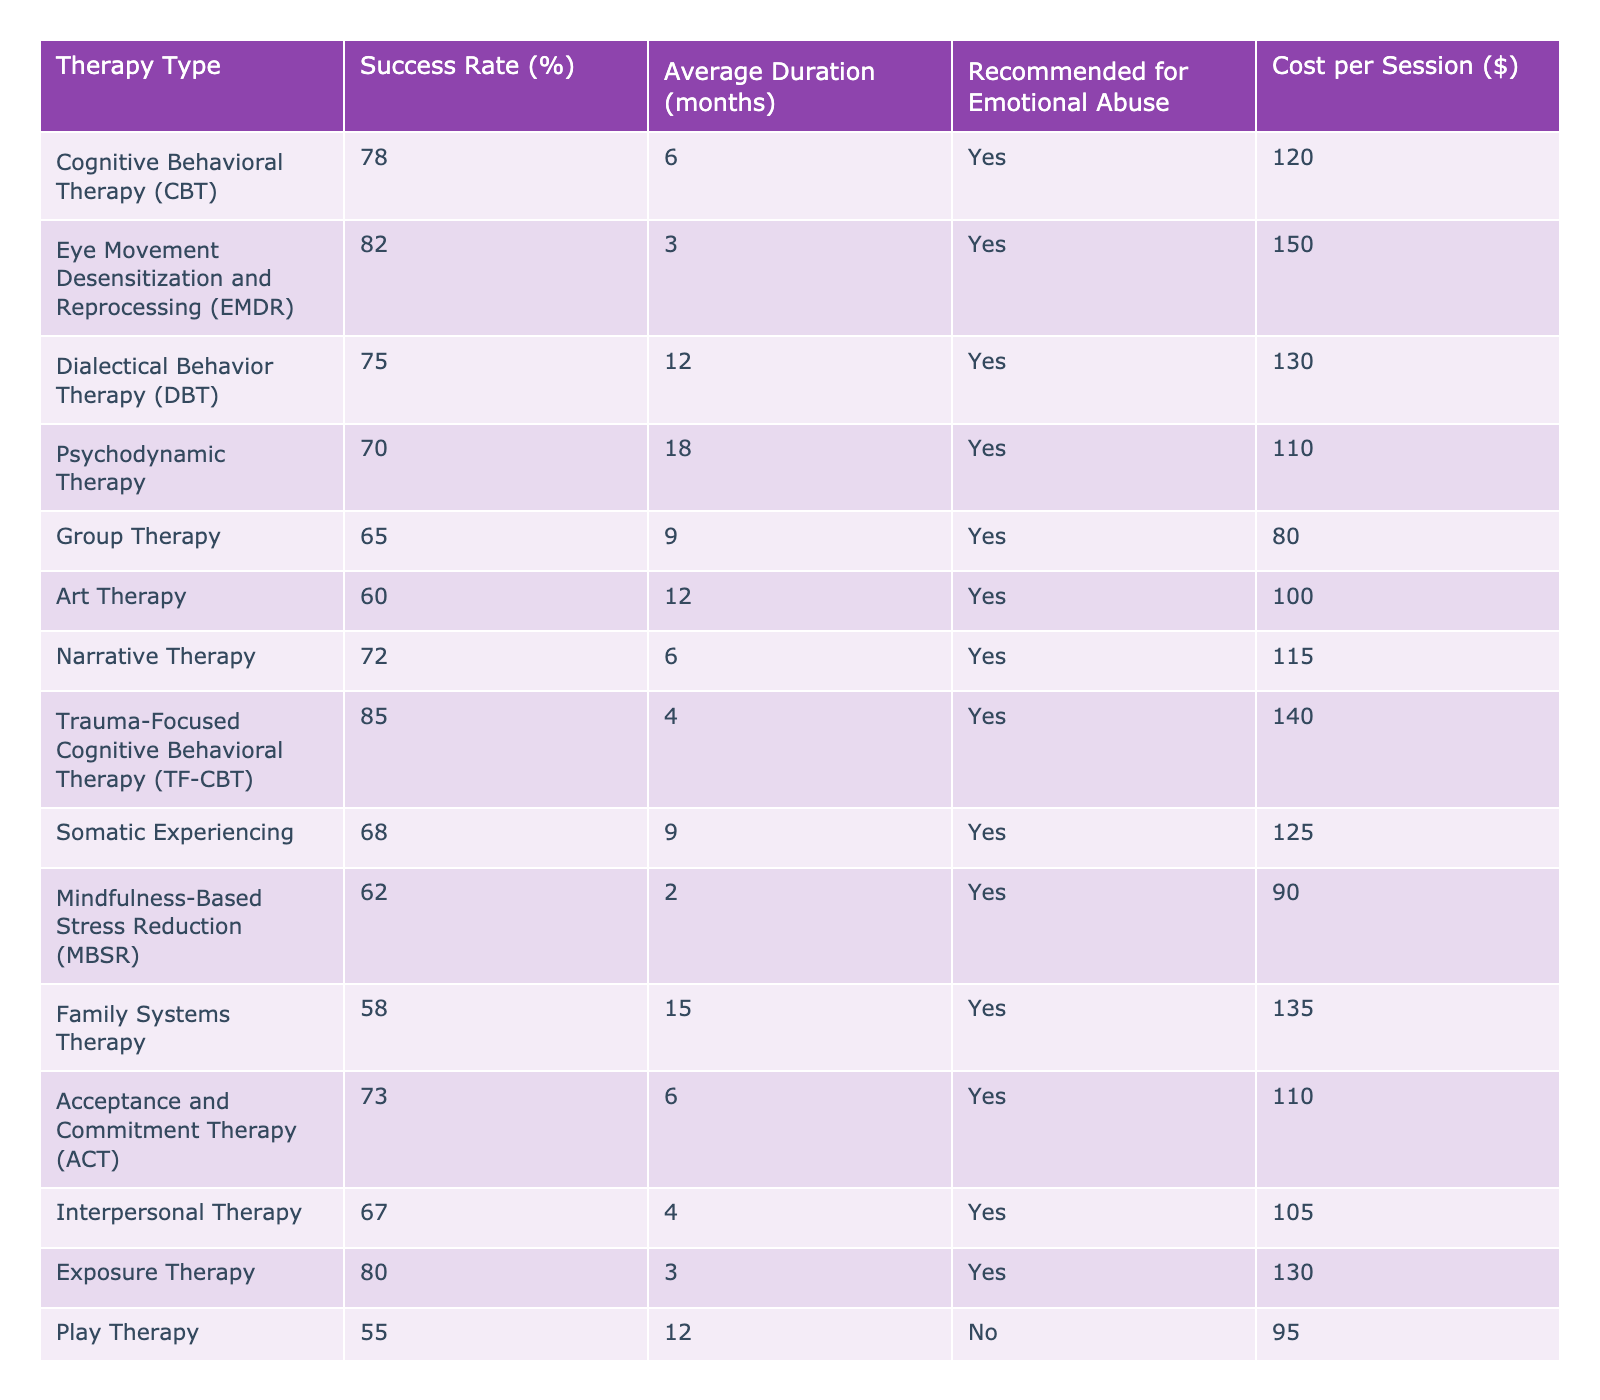What is the success rate of Eye Movement Desensitization and Reprocessing (EMDR)? The success rate for EMDR is listed directly in the table under the column for success rates. It shows 82%.
Answer: 82% Which therapy type has the lowest success rate for emotional abuse? Looking at the success rates of the therapies specifically recommended for emotional abuse, Play Therapy has the lowest success rate at 55%.
Answer: Play Therapy How much does Cognitive Behavioral Therapy (CBT) cost per session? The cost per session for CBT can be found in the table, specifically under the cost per session column, which shows 120 dollars.
Answer: 120 Which therapy type requires the longest average duration? Checking the average duration column, Psychodynamic Therapy has the longest duration at 18 months.
Answer: Psychodynamic Therapy What’s the average success rate of therapies that are recommended for emotional abuse? To find the average success rate, sum the success rates of the therapies recommended for emotional abuse (78 + 82 + 75 + 70 + 65 + 60 + 72 + 85 + 68 + 62 + 58 + 73 + 67 + 80 + 55) and divide by the number of therapies (15), which gives (78 + 82 + 75 + 70 + 65 + 60 + 72 + 85 + 68 + 62 + 58 + 73 + 67 + 80 + 55) / 15 = 70.2%.
Answer: 70.2% Is there a therapy type that is not recommended for emotional abuse? The table explicitly lists whether each therapy is recommended for emotional abuse. Play Therapy shows "No" in that column, indicating it's not recommended.
Answer: Yes How does the success rate of Trauma-Focused Cognitive Behavioral Therapy (TF-CBT) compare to that of Group Therapy? The success rate for TF-CBT is 85%, while the success rate for Group Therapy is 65%. Comparing these two values shows that TF-CBT has a higher success rate by 20%.
Answer: TF-CBT is higher by 20% Which therapy has the shortest average duration? The average duration column lists Mindfulness-Based Stress Reduction (MBSR) at an average duration of 2 months, making it the shortest.
Answer: Mindfulness-Based Stress Reduction (MBSR) What is the total cost per session for all therapy types recommended for emotional abuse? To find the total cost, sum the costs for the therapies recommended for emotional abuse (120 + 150 + 130 + 110 + 80 + 100 + 115 + 140 + 125 + 90 + 135 + 110 + 105 + 130), which equals $1,495.
Answer: 1495 What therapy type has a success rate of 75%? The therapy types column shows that both Cognitive Behavioral Therapy (CBT) and Dialectical Behavior Therapy (DBT) have a success rate of 75%.
Answer: CBT and DBT How many therapies have a success rate above 80%? By reviewing the success rates from the table, Trauma-Focused Cognitive Behavioral Therapy (TF-CBT), Eye Movement Desensitization and Reprocessing (EMDR), and Exposure Therapy have success rates above 80%, totaling 3 therapy types.
Answer: 3 